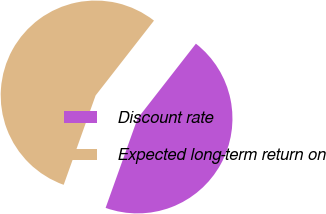Convert chart. <chart><loc_0><loc_0><loc_500><loc_500><pie_chart><fcel>Discount rate<fcel>Expected long-term return on<nl><fcel>44.92%<fcel>55.08%<nl></chart> 